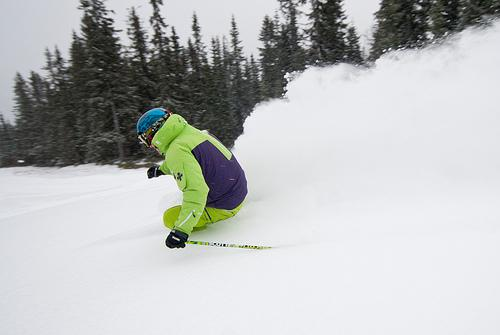Question: why is the snow churned up?
Choices:
A. From a blender.
B. From a tornado.
C. From the person's skis.
D. From an egg beater.
Answer with the letter. Answer: C Question: how is this person moving?
Choices:
A. Uphill.
B. Sideways.
C. Up and down.
D. Downhill.
Answer with the letter. Answer: D Question: when is it?
Choices:
A. Night.
B. Dusk.
C. Lunch time.
D. Day time.
Answer with the letter. Answer: D Question: what two colors are the person's jacket?
Choices:
A. Green and brown.
B. Green and blue.
C. Yellow and blue.
D. Black and blue.
Answer with the letter. Answer: B Question: what is in the person's hands?
Choices:
A. Ski poles.
B. Hockey sticks.
C. Tennis rackets.
D. Stilts.
Answer with the letter. Answer: A Question: who is going down the slope?
Choices:
A. A snowboarder.
B. A sledder.
C. A skier.
D. A mountain climber.
Answer with the letter. Answer: C Question: where is this scene?
Choices:
A. An ice rink.
B. The ocean.
C. The beach.
D. A ski slope.
Answer with the letter. Answer: D 